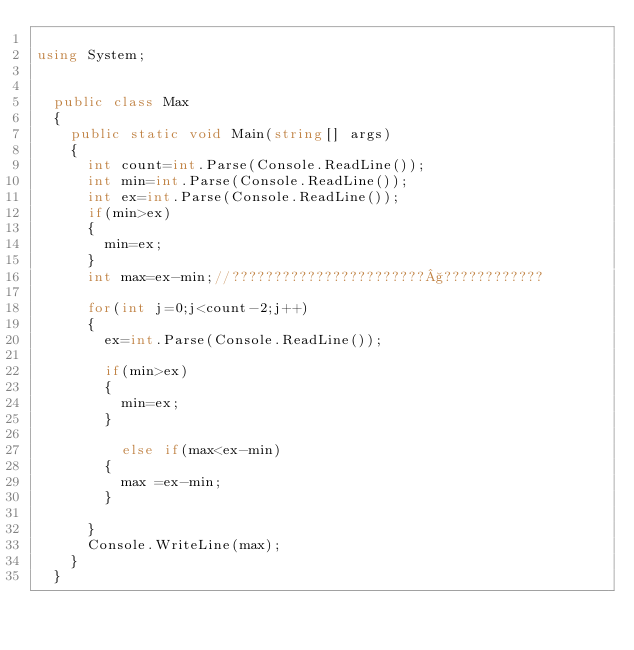Convert code to text. <code><loc_0><loc_0><loc_500><loc_500><_C#_>
using System;


	public class Max
	{
		public static void Main(string[] args)
		{
			int count=int.Parse(Console.ReadLine());			
			int min=int.Parse(Console.ReadLine());
			int ex=int.Parse(Console.ReadLine());
			if(min>ex)
			{
				min=ex;
			}
			int max=ex-min;//???????????????????????§????????????
			
			for(int j=0;j<count-2;j++)
			{
				ex=int.Parse(Console.ReadLine());
				
				if(min>ex)
				{
					min=ex;
				}
				
			    else if(max<ex-min)
				{
					max =ex-min;
				}
				
			}
			Console.WriteLine(max);
		}
	}</code> 